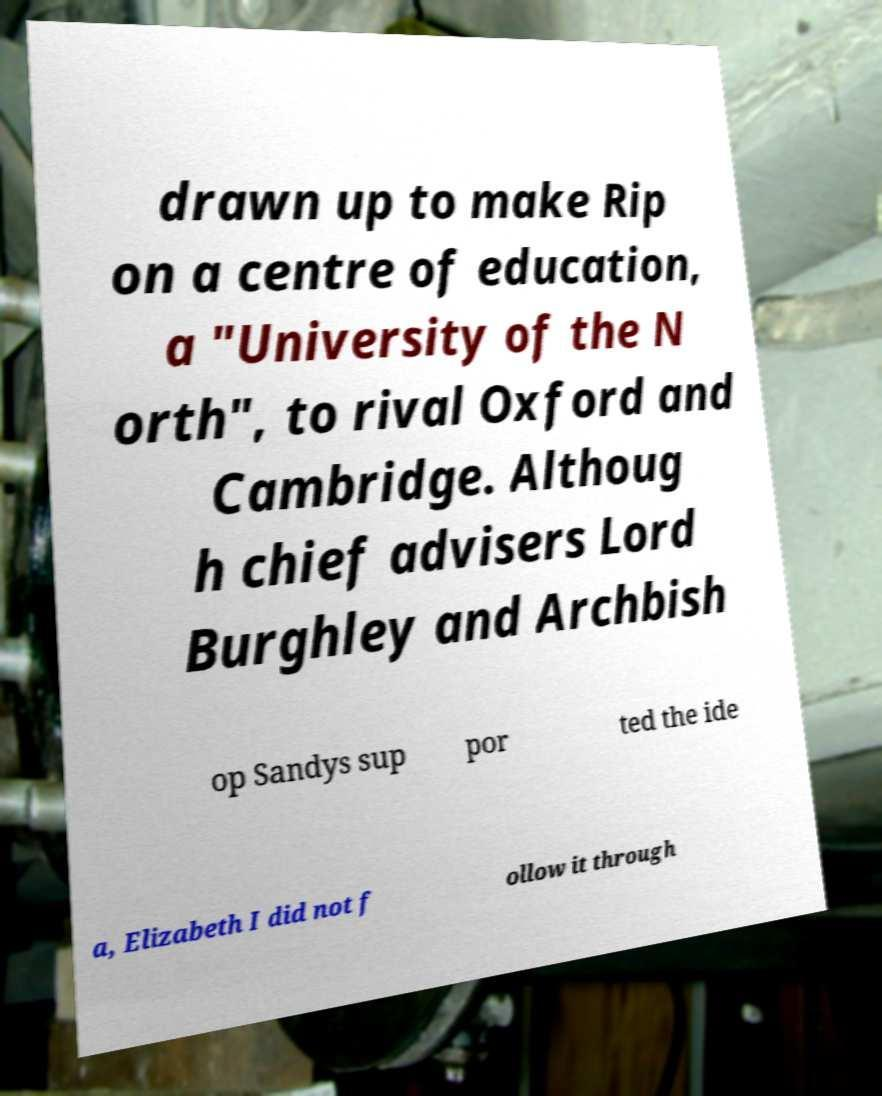What messages or text are displayed in this image? I need them in a readable, typed format. drawn up to make Rip on a centre of education, a "University of the N orth", to rival Oxford and Cambridge. Althoug h chief advisers Lord Burghley and Archbish op Sandys sup por ted the ide a, Elizabeth I did not f ollow it through 